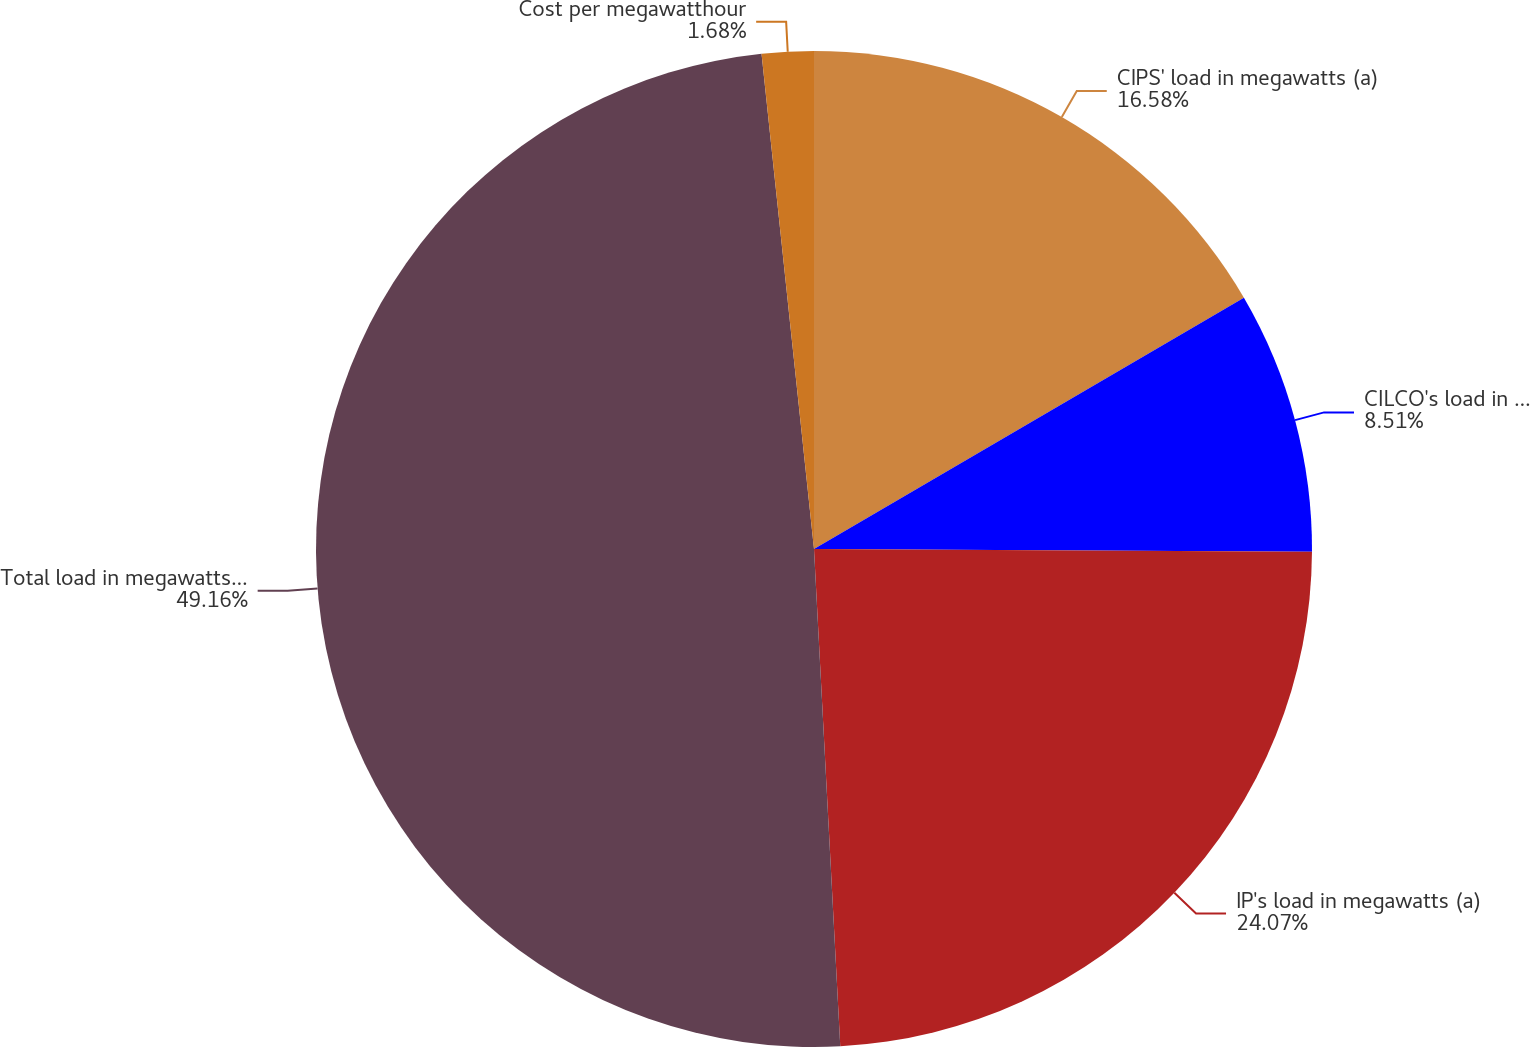Convert chart. <chart><loc_0><loc_0><loc_500><loc_500><pie_chart><fcel>CIPS' load in megawatts (a)<fcel>CILCO's load in megawatts (a)<fcel>IP's load in megawatts (a)<fcel>Total load in megawatts (a)<fcel>Cost per megawatthour<nl><fcel>16.58%<fcel>8.51%<fcel>24.07%<fcel>49.16%<fcel>1.68%<nl></chart> 